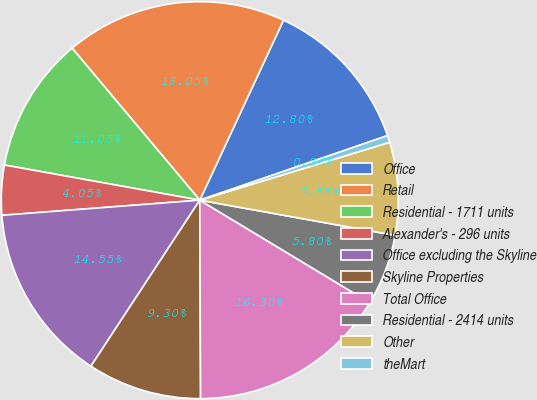Convert chart. <chart><loc_0><loc_0><loc_500><loc_500><pie_chart><fcel>Office<fcel>Retail<fcel>Residential - 1711 units<fcel>Alexander's - 296 units<fcel>Office excluding the Skyline<fcel>Skyline Properties<fcel>Total Office<fcel>Residential - 2414 units<fcel>Other<fcel>theMart<nl><fcel>12.8%<fcel>18.05%<fcel>11.05%<fcel>4.05%<fcel>14.55%<fcel>9.3%<fcel>16.3%<fcel>5.8%<fcel>7.55%<fcel>0.56%<nl></chart> 